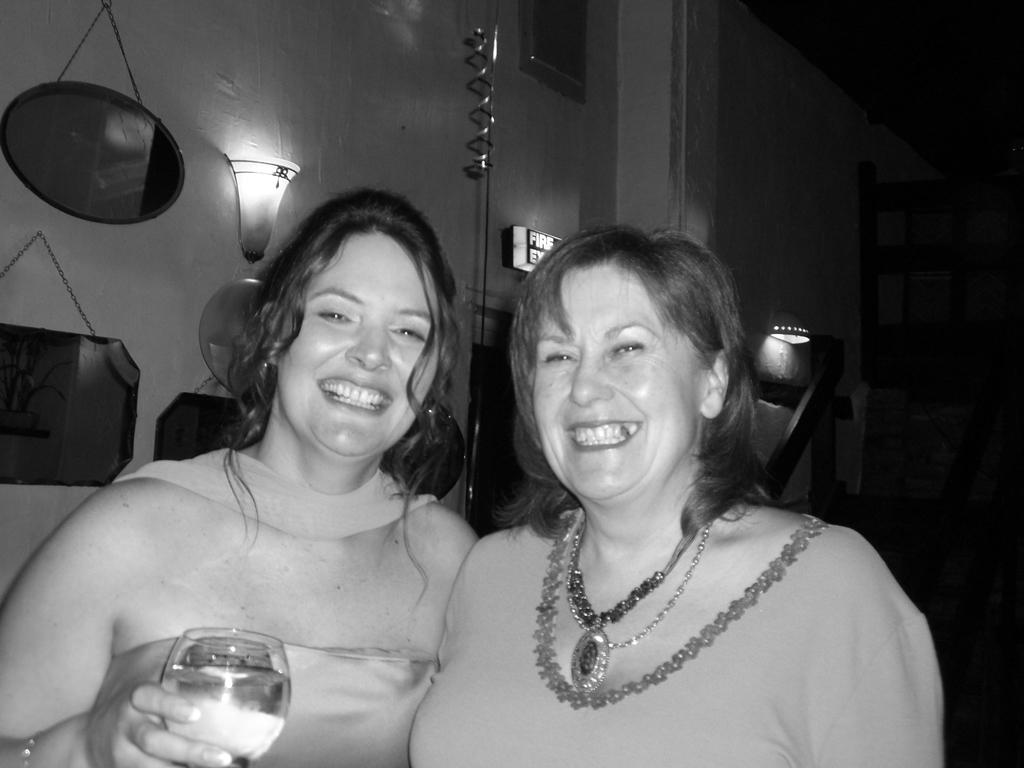How many people are in the image? There are two women in the image. What is the facial expression of the women? Both women are smiling. What is one of the women holding in the image? One of the women is holding a glass with water in it. What can be seen in the background of the image? There is a wall with frames and a light in the background of the image. What type of cracker is visible in the image? There is no cracker present in the image; it only shows two women, one holding a glass of water. 